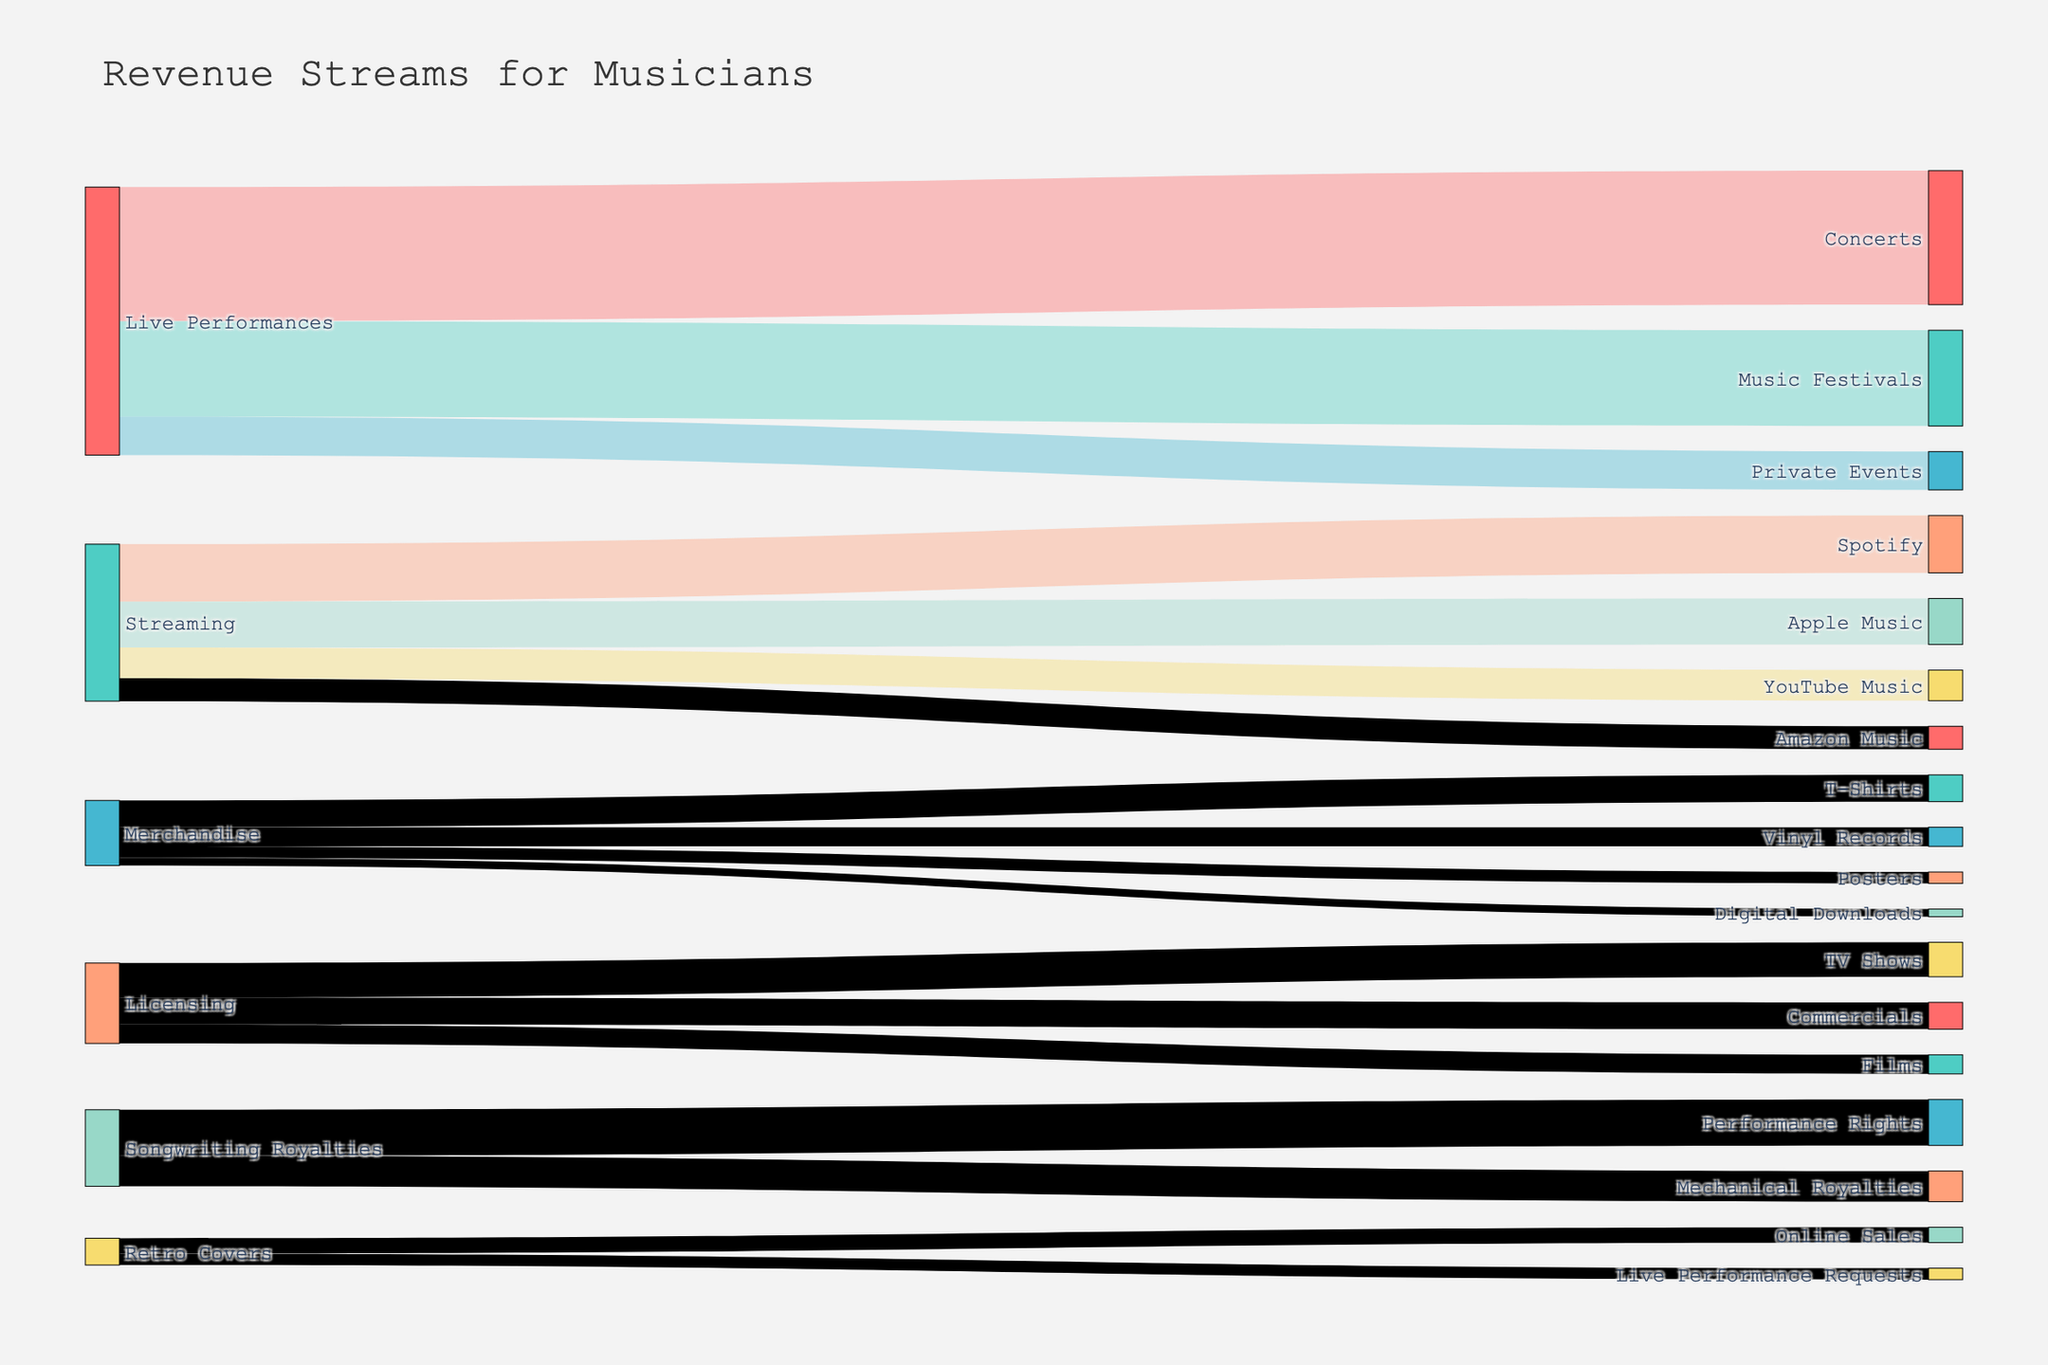What are the main sources of revenue for musicians according to the diagram? The main sources of revenue as shown in the diagram are Live Performances, Streaming, Merchandise, Licensing, Songwriting Royalties, and Retro Covers.
Answer: Live Performances, Streaming, Merchandise, Licensing, Songwriting Royalties, Retro Covers How much total revenue comes from Live Performances? To find the total revenue from Live Performances, sum the values of Concerts, Music Festivals, and Private Events. \( 35000 + 25000 + 10000 = 70000 \)
Answer: 70000 Which category has the highest individual revenue stream and what is it? The category with the highest individual revenue stream is Live Performances with Concerts generating 35000 in revenue. This is the single highest value among all streams.
Answer: Concerts, 35000 How does the revenue from Streaming on Spotify compare to Streaming on Apple Music? To compare, look at the values for both; Spotify has 15000, and Apple Music has 12000. Spotify generates more revenue than Apple Music by 3000.
Answer: Spotify is higher by 3000 What is the combined revenue from all Streaming sources? Add the values from Spotify, Apple Music, YouTube Music, and Amazon Music to get the total streaming revenue. \( 15000 + 12000 + 8000 + 6000 = 41000 \)
Answer: 41000 How much more revenue do Live Performances generate compared to Merchandise? Sum the values of Live Performances and Merrchandise and then find the difference. \( 70000 - (7000 + 5000 + 3000 + 2000) = 70000 - 17000 = 53000 \)
Answer: 53000 more Which revenue stream under Merchandise generates the least income? The diagram indicates that Digital Downloads under Merchandise generates the least income with a value of 2000.
Answer: Digital Downloads What is the total revenue from all categories combined? Add the total revenues from each main category: \( 70000 \text{(Live Performances)} + 41000 \text{(Streaming)} + 17000 \text{(Merchandise)} + 21000 \text{(Licensing)} + 20000 \text{(Songwriting Royalties)} + 7000 \text{(Retro Covers)} \). \( 70000 + 41000 + 17000 + 21000 + 20000 + 7000 = 176000 \)
Answer: 176000 How does the revenue from Licensing compare to that from Songwriting Royalties? Licensing has a total revenue of 21000, while Songwriting Royalties total 20000. Licensing generates 1000 more in revenue than Songwriting Royalties.
Answer: Licensing is higher by 1000 